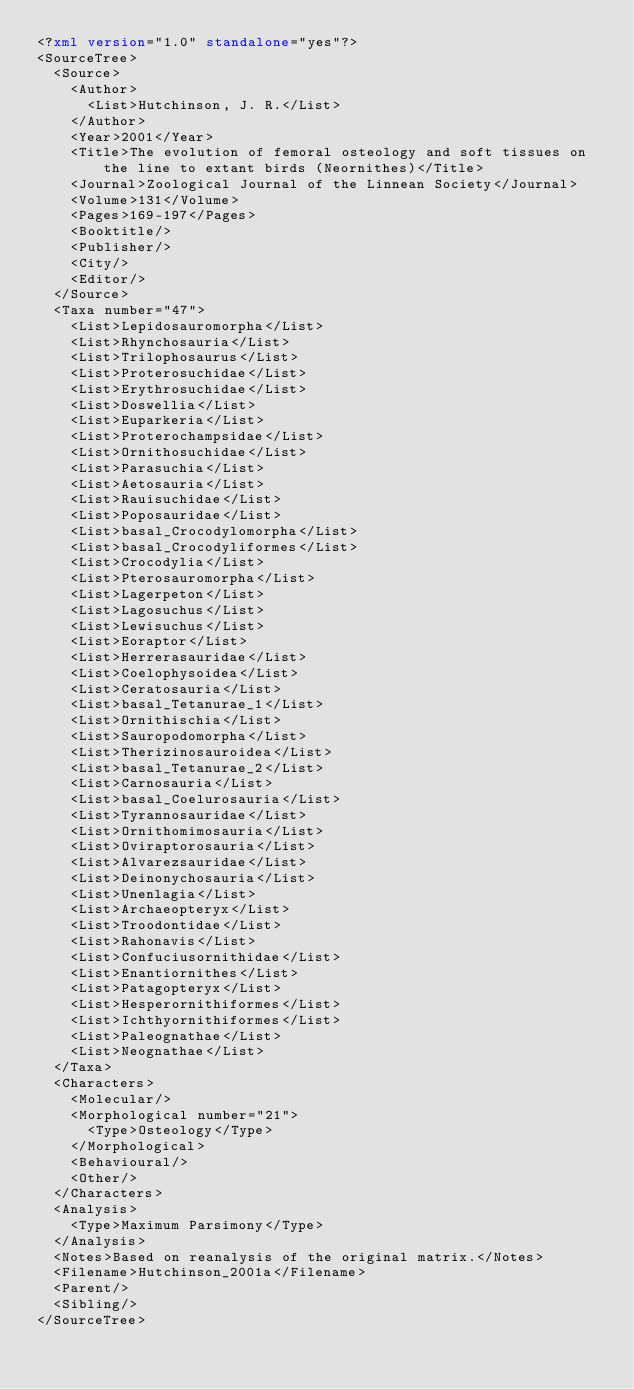Convert code to text. <code><loc_0><loc_0><loc_500><loc_500><_XML_><?xml version="1.0" standalone="yes"?>
<SourceTree>
	<Source>
		<Author>
			<List>Hutchinson, J. R.</List>
		</Author>
		<Year>2001</Year>
		<Title>The evolution of femoral osteology and soft tissues on the line to extant birds (Neornithes)</Title>
		<Journal>Zoological Journal of the Linnean Society</Journal>
		<Volume>131</Volume>
		<Pages>169-197</Pages>
		<Booktitle/>
		<Publisher/>
		<City/>
		<Editor/>
	</Source>
	<Taxa number="47">
		<List>Lepidosauromorpha</List>
		<List>Rhynchosauria</List>
		<List>Trilophosaurus</List>
		<List>Proterosuchidae</List>
		<List>Erythrosuchidae</List>
		<List>Doswellia</List>
		<List>Euparkeria</List>
		<List>Proterochampsidae</List>
		<List>Ornithosuchidae</List>
		<List>Parasuchia</List>
		<List>Aetosauria</List>
		<List>Rauisuchidae</List>
		<List>Poposauridae</List>
		<List>basal_Crocodylomorpha</List>
		<List>basal_Crocodyliformes</List>
		<List>Crocodylia</List>
		<List>Pterosauromorpha</List>
		<List>Lagerpeton</List>
		<List>Lagosuchus</List>
		<List>Lewisuchus</List>
		<List>Eoraptor</List>
		<List>Herrerasauridae</List>
		<List>Coelophysoidea</List>
		<List>Ceratosauria</List>
		<List>basal_Tetanurae_1</List>
		<List>Ornithischia</List>
		<List>Sauropodomorpha</List>
		<List>Therizinosauroidea</List>
		<List>basal_Tetanurae_2</List>
		<List>Carnosauria</List>
		<List>basal_Coelurosauria</List>
		<List>Tyrannosauridae</List>
		<List>Ornithomimosauria</List>
		<List>Oviraptorosauria</List>
		<List>Alvarezsauridae</List>
		<List>Deinonychosauria</List>
		<List>Unenlagia</List>
		<List>Archaeopteryx</List>
		<List>Troodontidae</List>
		<List>Rahonavis</List>
		<List>Confuciusornithidae</List>
		<List>Enantiornithes</List>
		<List>Patagopteryx</List>
		<List>Hesperornithiformes</List>
		<List>Ichthyornithiformes</List>
		<List>Paleognathae</List>
		<List>Neognathae</List>
	</Taxa>
	<Characters>
		<Molecular/>
		<Morphological number="21">
			<Type>Osteology</Type>
		</Morphological>
		<Behavioural/>
		<Other/>
	</Characters>
	<Analysis>
		<Type>Maximum Parsimony</Type>
	</Analysis>
	<Notes>Based on reanalysis of the original matrix.</Notes>
	<Filename>Hutchinson_2001a</Filename>
	<Parent/>
	<Sibling/>
</SourceTree>
</code> 